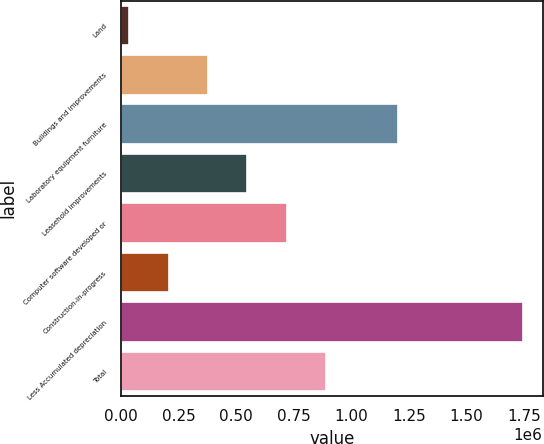Convert chart to OTSL. <chart><loc_0><loc_0><loc_500><loc_500><bar_chart><fcel>Land<fcel>Buildings and improvements<fcel>Laboratory equipment furniture<fcel>Leasehold improvements<fcel>Computer software developed or<fcel>Construction-in-progress<fcel>Less Accumulated depreciation<fcel>Total<nl><fcel>35786<fcel>377332<fcel>1.20382e+06<fcel>548106<fcel>718879<fcel>206559<fcel>1.74352e+06<fcel>889652<nl></chart> 